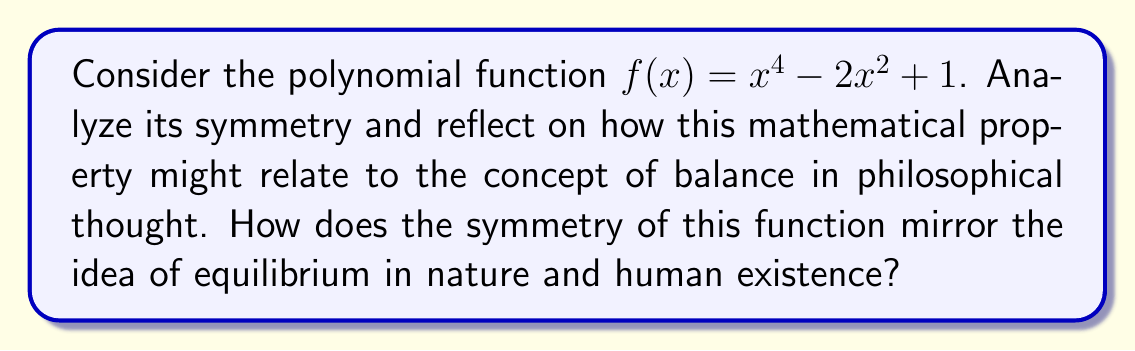Help me with this question. To analyze the symmetry of the given polynomial function $f(x) = x^4 - 2x^2 + 1$, we need to consider its behavior when reflected across the y-axis:

1. First, let's check if $f(-x) = f(x)$ for all $x$:

   $f(-x) = (-x)^4 - 2(-x)^2 + 1$
   $= x^4 - 2x^2 + 1$
   $= f(x)$

2. Since $f(-x) = f(x)$, the function is even and symmetric about the y-axis.

3. To visualize this symmetry, we can graph the function:

[asy]
import graph;
size(200);
real f(real x) {return x^4 - 2x^2 + 1;}
draw(graph(f, -2, 2), blue);
draw((-2,0)--(2,0), arrow=Arrow);
draw((0,-1)--(0,3), arrow=Arrow);
label("x", (2,0), E);
label("y", (0,3), N);
[/asy]

The graph clearly shows symmetry about the y-axis.

Philosophical implications:

1. Balance and Duality: The symmetry of this function reflects the philosophical concept of balance and duality in nature. Just as the function maintains perfect equilibrium around the y-axis, many philosophical traditions emphasize the importance of balance in life and the universe.

2. Cyclical Nature of Existence: The shape of the graph, with its two minima and central maximum, can be seen as a representation of life's ups and downs, or the cyclical nature of existence proposed in some Eastern philosophies.

3. Unity of Opposites: The symmetry demonstrates how seemingly opposite sides of the graph are actually part of the same unified whole, echoing philosophical ideas about the unity of opposites or the complementary nature of contrasting forces (e.g., yin and yang).

4. Mathematical Beauty and Platonic Ideals: The perfect symmetry of this function might be seen as an example of mathematical beauty, relating to Platonic ideas about perfect forms existing in an ideal realm.

5. Determinism vs. Free Will: The predictable nature of the function's symmetry could be used to reflect on questions of determinism versus free will in human existence.

6. Reflection and Self-awareness: The symmetry can be interpreted as a metaphor for self-reflection and self-awareness, core concepts in many philosophical traditions.

This analysis demonstrates how mathematical properties like symmetry can serve as powerful metaphors for complex philosophical ideas, bridging the gap between abstract mathematical concepts and fundamental questions about existence and reality.
Answer: The polynomial function $f(x) = x^4 - 2x^2 + 1$ is symmetric about the y-axis (even function). This symmetry can be interpreted as a mathematical representation of balance, duality, and cyclical patterns in nature and human existence, offering a bridge between mathematical concepts and philosophical contemplation on equilibrium and the nature of reality. 